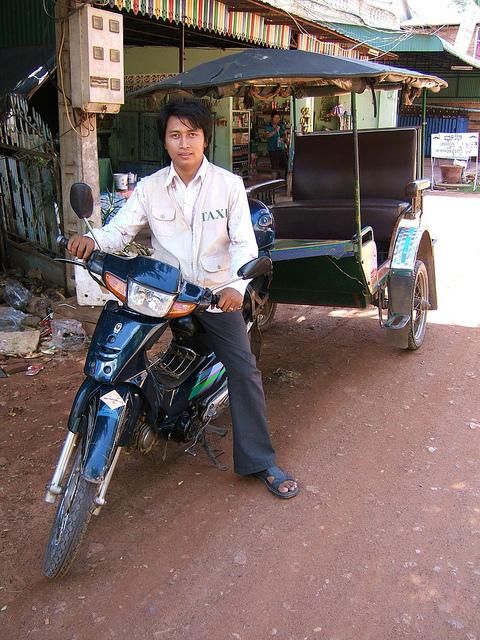Is it likely this man is offering free rides?
Answer briefly. No. What is the man riding?
Answer briefly. Motorcycle. What color is the ground?
Write a very short answer. Brown. 